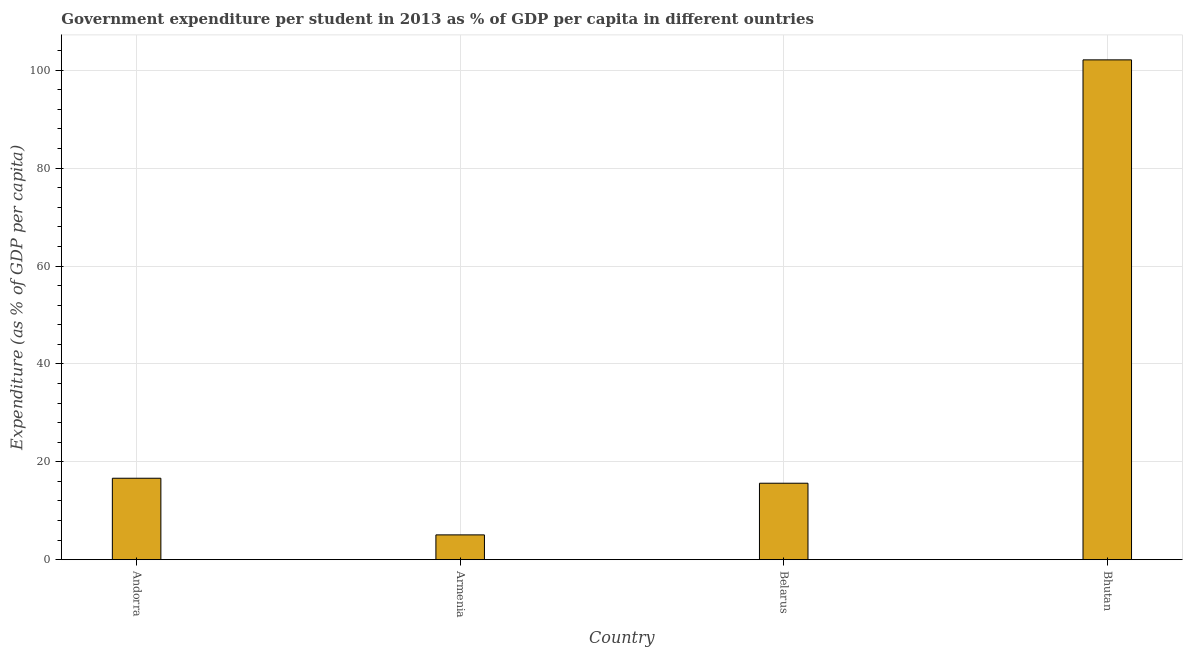Does the graph contain any zero values?
Offer a very short reply. No. What is the title of the graph?
Your answer should be compact. Government expenditure per student in 2013 as % of GDP per capita in different ountries. What is the label or title of the X-axis?
Your answer should be compact. Country. What is the label or title of the Y-axis?
Offer a terse response. Expenditure (as % of GDP per capita). What is the government expenditure per student in Andorra?
Give a very brief answer. 16.64. Across all countries, what is the maximum government expenditure per student?
Your response must be concise. 102.12. Across all countries, what is the minimum government expenditure per student?
Your response must be concise. 5.07. In which country was the government expenditure per student maximum?
Your response must be concise. Bhutan. In which country was the government expenditure per student minimum?
Make the answer very short. Armenia. What is the sum of the government expenditure per student?
Ensure brevity in your answer.  139.45. What is the difference between the government expenditure per student in Armenia and Belarus?
Your answer should be compact. -10.55. What is the average government expenditure per student per country?
Give a very brief answer. 34.86. What is the median government expenditure per student?
Make the answer very short. 16.13. What is the ratio of the government expenditure per student in Belarus to that in Bhutan?
Make the answer very short. 0.15. Is the government expenditure per student in Andorra less than that in Bhutan?
Provide a succinct answer. Yes. What is the difference between the highest and the second highest government expenditure per student?
Provide a succinct answer. 85.48. Is the sum of the government expenditure per student in Andorra and Armenia greater than the maximum government expenditure per student across all countries?
Your response must be concise. No. What is the difference between the highest and the lowest government expenditure per student?
Offer a terse response. 97.06. How many bars are there?
Offer a very short reply. 4. Are all the bars in the graph horizontal?
Offer a terse response. No. Are the values on the major ticks of Y-axis written in scientific E-notation?
Offer a very short reply. No. What is the Expenditure (as % of GDP per capita) in Andorra?
Your response must be concise. 16.64. What is the Expenditure (as % of GDP per capita) in Armenia?
Your response must be concise. 5.07. What is the Expenditure (as % of GDP per capita) of Belarus?
Offer a terse response. 15.62. What is the Expenditure (as % of GDP per capita) in Bhutan?
Offer a very short reply. 102.12. What is the difference between the Expenditure (as % of GDP per capita) in Andorra and Armenia?
Keep it short and to the point. 11.57. What is the difference between the Expenditure (as % of GDP per capita) in Andorra and Belarus?
Keep it short and to the point. 1.02. What is the difference between the Expenditure (as % of GDP per capita) in Andorra and Bhutan?
Make the answer very short. -85.49. What is the difference between the Expenditure (as % of GDP per capita) in Armenia and Belarus?
Your answer should be compact. -10.55. What is the difference between the Expenditure (as % of GDP per capita) in Armenia and Bhutan?
Offer a very short reply. -97.06. What is the difference between the Expenditure (as % of GDP per capita) in Belarus and Bhutan?
Your response must be concise. -86.5. What is the ratio of the Expenditure (as % of GDP per capita) in Andorra to that in Armenia?
Your response must be concise. 3.28. What is the ratio of the Expenditure (as % of GDP per capita) in Andorra to that in Belarus?
Ensure brevity in your answer.  1.06. What is the ratio of the Expenditure (as % of GDP per capita) in Andorra to that in Bhutan?
Make the answer very short. 0.16. What is the ratio of the Expenditure (as % of GDP per capita) in Armenia to that in Belarus?
Offer a very short reply. 0.32. What is the ratio of the Expenditure (as % of GDP per capita) in Belarus to that in Bhutan?
Give a very brief answer. 0.15. 